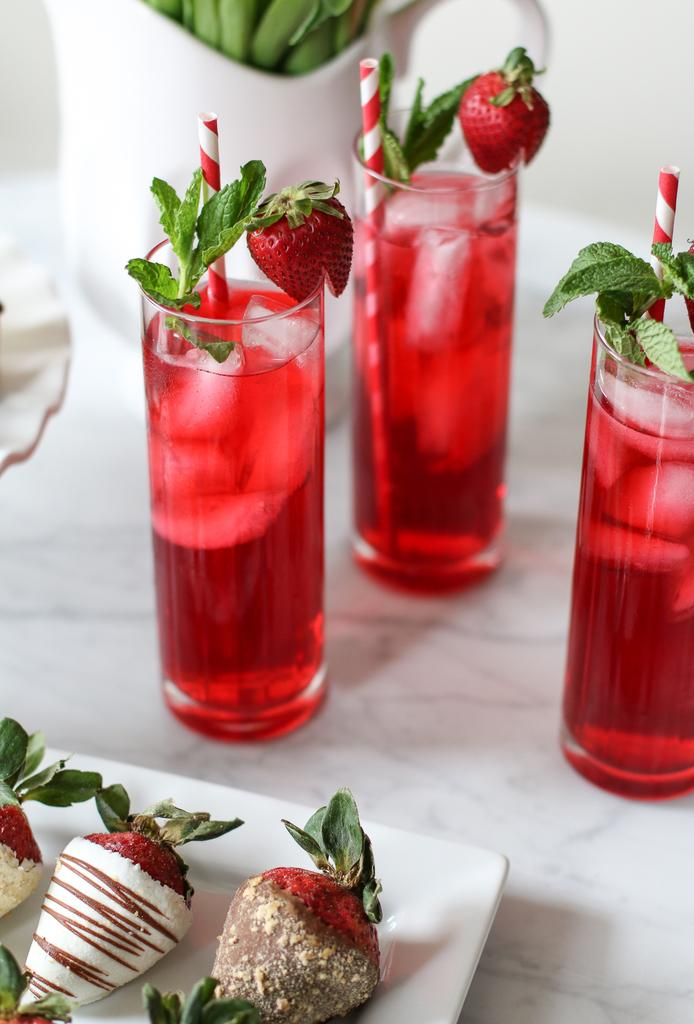What is on the plate that is visible in the image? There are objects on a white color plate in the image. Where is the plate located? The plate is on a table in the image. What else can be seen on the table? There are glasses filled with juice on the table. What is near the white wall can be seen in the image? There are other objects near a white wall in the image. Is there any popcorn being served for payment in the image? There is no mention of popcorn or payment in the image; it only shows objects on a plate, glasses filled with juice, and other objects near a white wall. 